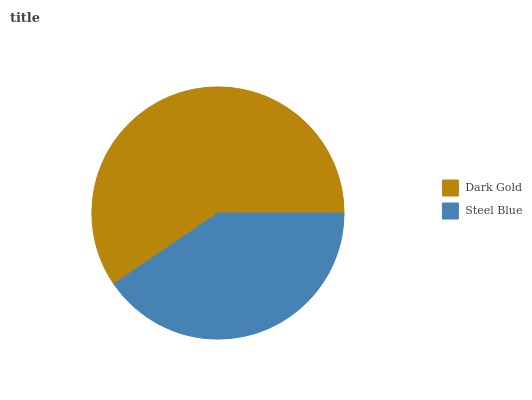Is Steel Blue the minimum?
Answer yes or no. Yes. Is Dark Gold the maximum?
Answer yes or no. Yes. Is Steel Blue the maximum?
Answer yes or no. No. Is Dark Gold greater than Steel Blue?
Answer yes or no. Yes. Is Steel Blue less than Dark Gold?
Answer yes or no. Yes. Is Steel Blue greater than Dark Gold?
Answer yes or no. No. Is Dark Gold less than Steel Blue?
Answer yes or no. No. Is Dark Gold the high median?
Answer yes or no. Yes. Is Steel Blue the low median?
Answer yes or no. Yes. Is Steel Blue the high median?
Answer yes or no. No. Is Dark Gold the low median?
Answer yes or no. No. 